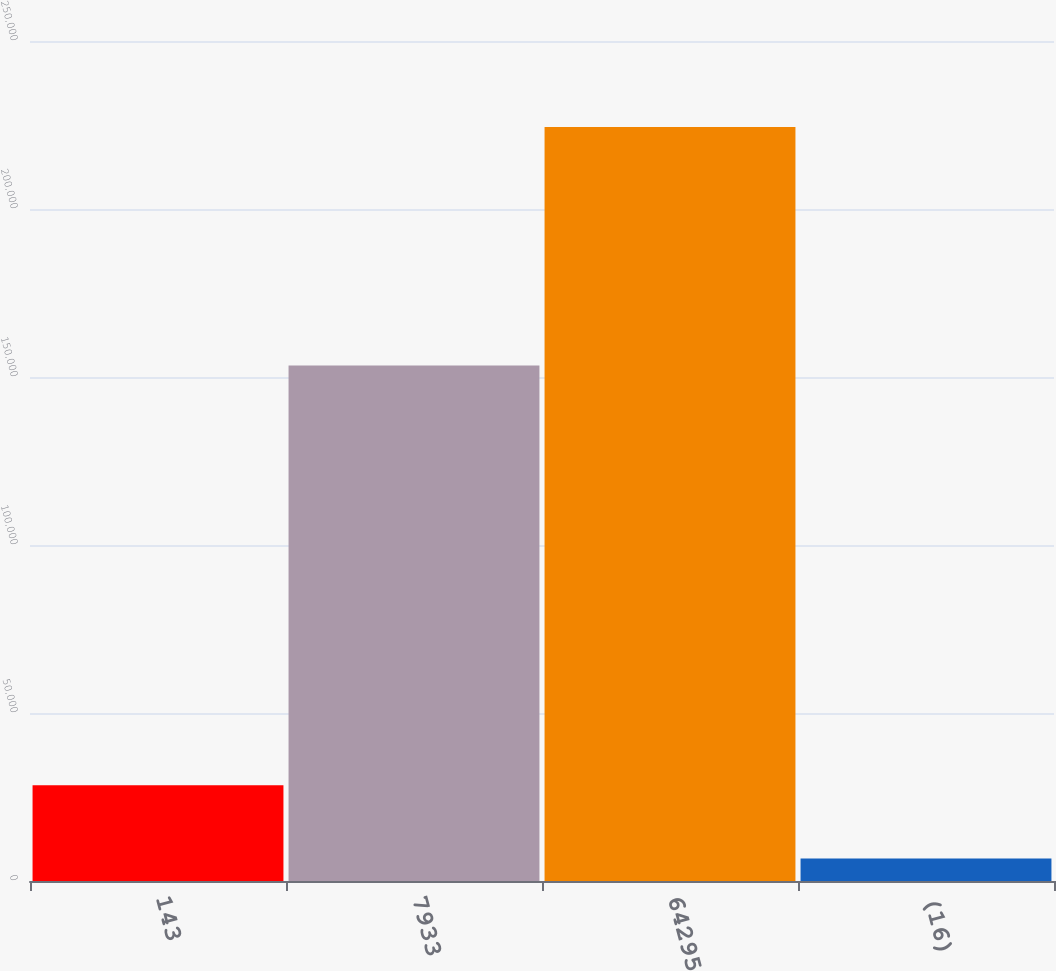Convert chart. <chart><loc_0><loc_0><loc_500><loc_500><bar_chart><fcel>143<fcel>7933<fcel>64295<fcel>(16)<nl><fcel>28461<fcel>153429<fcel>224382<fcel>6692<nl></chart> 